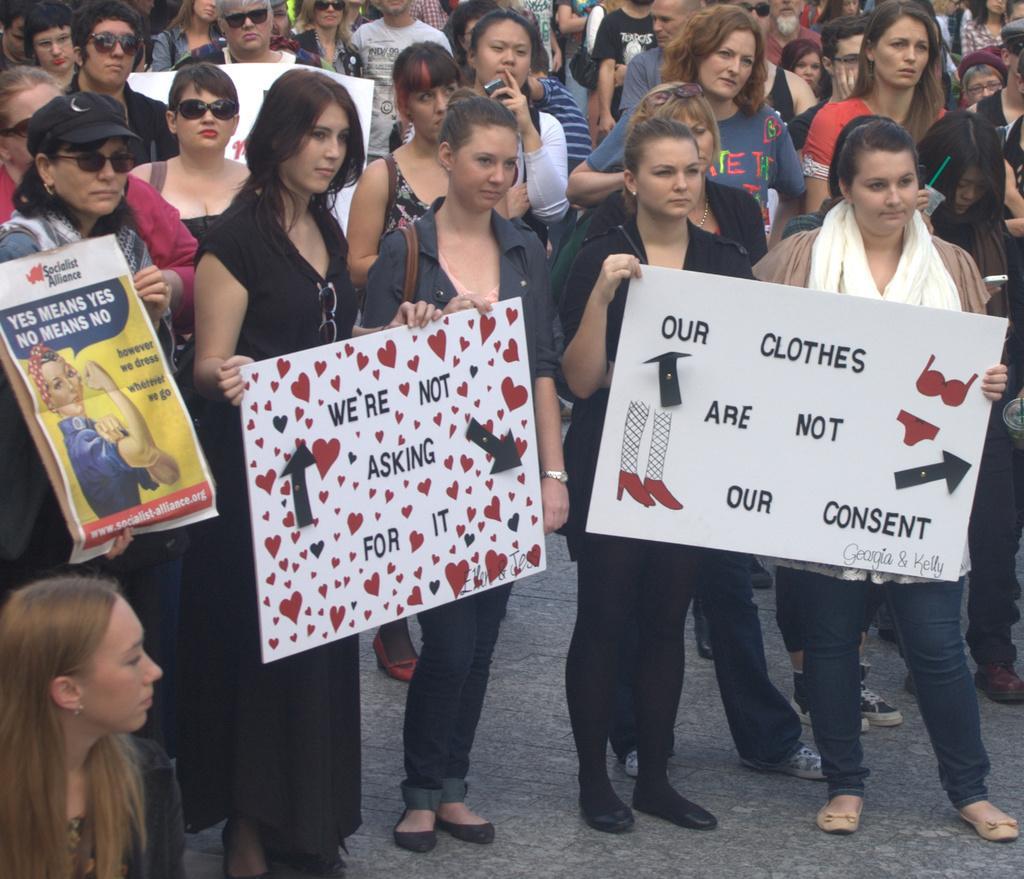In one or two sentences, can you explain what this image depicts? In this image, we can see a group of people are standing. Few people are holding some objects. At the bottom, we can see the path. 